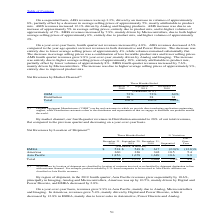According to Stmicroelectronics's financial document, What are Original Equipment Manufacturers? Original Equipment Manufacturers (“OEM”) are the end-customers to which we provide direct marketing application engineering support. The document states: "(1) Original Equipment Manufacturers (“OEM”) are the end-customers to which we provide direct marketing application engineering support, while Distrib..." Also, What are Distribution customers? Distribution customers refers to the distributors and representatives that we engage to distribute our products around the world.. The document states: "t marketing application engineering support, while Distribution customers refers to the distributors and representatives that we engage to distribute ..." Also, How much did the Distribution accounted for in the fourth quarter of total revenues? According to the financial document, 28%. The relevant text states: "ourth quarter revenues in Distribution amounted to 28% of our total revenues, flat compared to the previous quarter and decreasing on a year-over-year basi..." Also, can you calculate: What is the average net revenues from OEM for the period December 31, 2019 and 2018? To answer this question, I need to perform calculations using the financial data. The calculation is: (72+69) / 2, which equals 70.5 (percentage). This is based on the information: "OEM 72% 72% 69% OEM 72% 72% 69%..." The key data points involved are: 69, 72. Also, can you calculate: What is the average net revenues from Distribution for the period December 31, 2019 and 2018? To answer this question, I need to perform calculations using the financial data. The calculation is: (28+31) / 2, which equals 29.5 (percentage). This is based on the information: "Distribution 28 28 31 Distribution 28 28 31..." The key data points involved are: 28, 31. Also, can you calculate: What is the increase/ (decrease) in OEM from the period December 31, 2018 to 2019? Based on the calculation: 72-69, the result is 3 (percentage). This is based on the information: "OEM 72% 72% 69% OEM 72% 72% 69%..." The key data points involved are: 69, 72. 